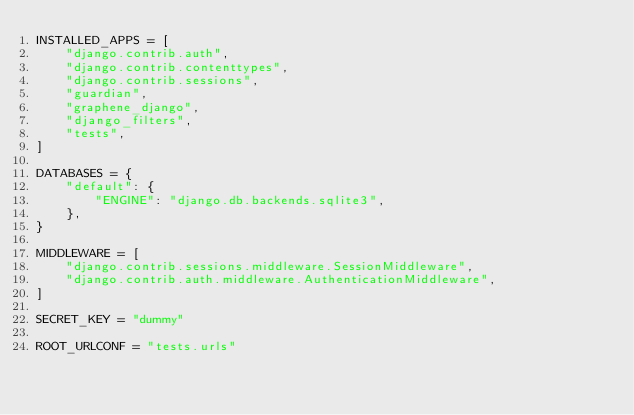Convert code to text. <code><loc_0><loc_0><loc_500><loc_500><_Python_>INSTALLED_APPS = [
    "django.contrib.auth",
    "django.contrib.contenttypes",
    "django.contrib.sessions",
    "guardian",
    "graphene_django",
    "django_filters",
    "tests",
]

DATABASES = {
    "default": {
        "ENGINE": "django.db.backends.sqlite3",
    },
}

MIDDLEWARE = [
    "django.contrib.sessions.middleware.SessionMiddleware",
    "django.contrib.auth.middleware.AuthenticationMiddleware",
]

SECRET_KEY = "dummy"

ROOT_URLCONF = "tests.urls"
</code> 